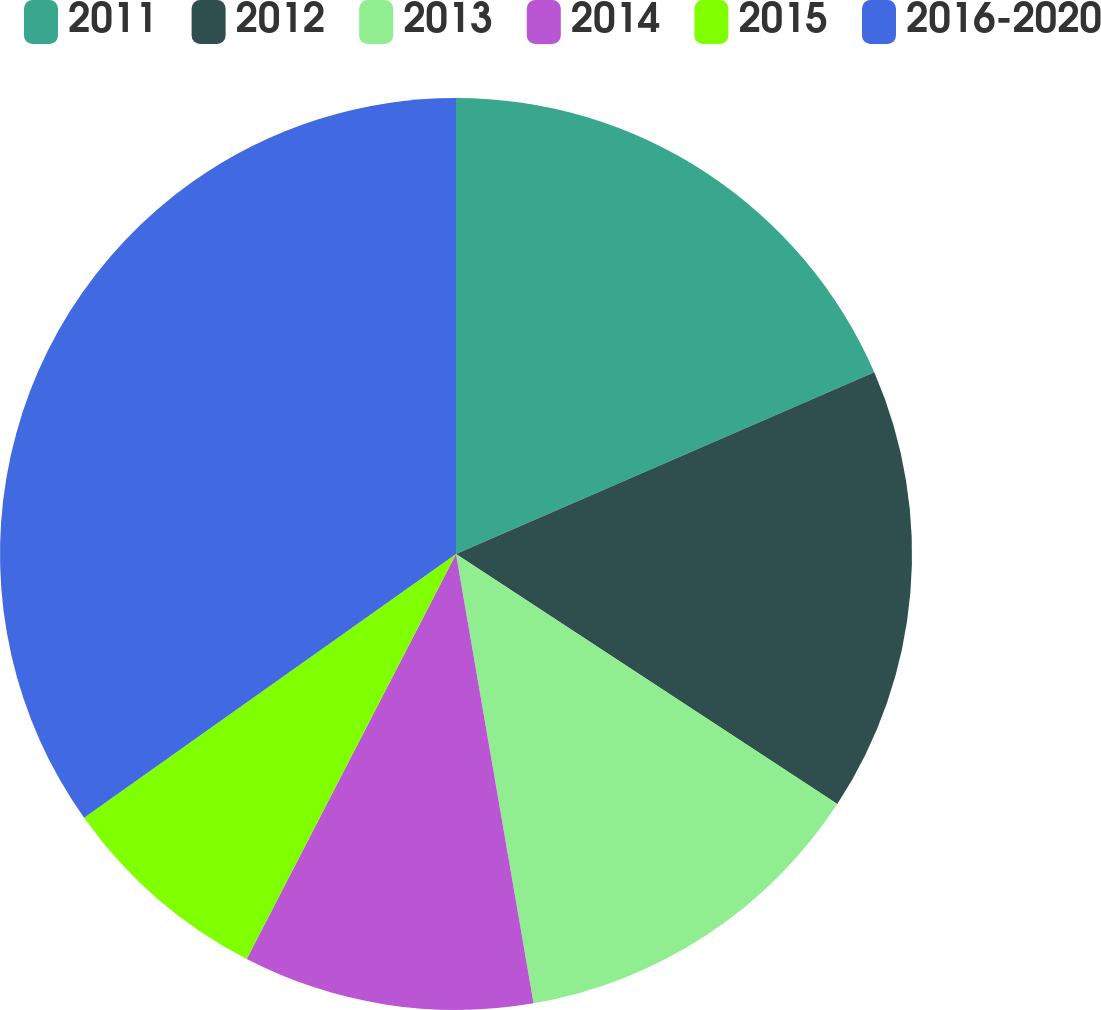Convert chart. <chart><loc_0><loc_0><loc_500><loc_500><pie_chart><fcel>2011<fcel>2012<fcel>2013<fcel>2014<fcel>2015<fcel>2016-2020<nl><fcel>18.48%<fcel>15.76%<fcel>13.04%<fcel>10.31%<fcel>7.59%<fcel>34.82%<nl></chart> 